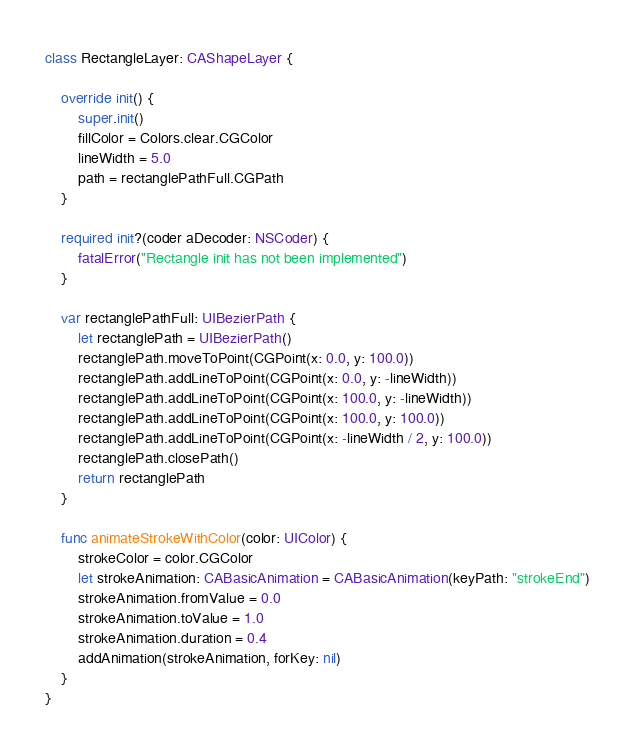<code> <loc_0><loc_0><loc_500><loc_500><_Swift_>
class RectangleLayer: CAShapeLayer {

    override init() {
        super.init()
        fillColor = Colors.clear.CGColor
        lineWidth = 5.0
        path = rectanglePathFull.CGPath
    }
    
    required init?(coder aDecoder: NSCoder) {
        fatalError("Rectangle init has not been implemented")
    }
    
    var rectanglePathFull: UIBezierPath {
        let rectanglePath = UIBezierPath()
        rectanglePath.moveToPoint(CGPoint(x: 0.0, y: 100.0))
        rectanglePath.addLineToPoint(CGPoint(x: 0.0, y: -lineWidth))
        rectanglePath.addLineToPoint(CGPoint(x: 100.0, y: -lineWidth))
        rectanglePath.addLineToPoint(CGPoint(x: 100.0, y: 100.0))
        rectanglePath.addLineToPoint(CGPoint(x: -lineWidth / 2, y: 100.0))
        rectanglePath.closePath()
        return rectanglePath
    }
    
    func animateStrokeWithColor(color: UIColor) {
        strokeColor = color.CGColor
        let strokeAnimation: CABasicAnimation = CABasicAnimation(keyPath: "strokeEnd")
        strokeAnimation.fromValue = 0.0
        strokeAnimation.toValue = 1.0
        strokeAnimation.duration = 0.4
        addAnimation(strokeAnimation, forKey: nil)
    }
}
</code> 